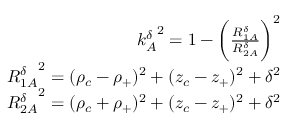<formula> <loc_0><loc_0><loc_500><loc_500>\begin{array} { r } { { k _ { A } ^ { \delta } } ^ { 2 } = 1 - \left ( \frac { R _ { 1 A } ^ { \delta } } { R _ { 2 A } ^ { \delta } } \right ) ^ { 2 } } \\ { { R _ { 1 A } ^ { \delta } } ^ { 2 } = ( \rho _ { c } - \rho _ { + } ) ^ { 2 } + ( z _ { c } - z _ { + } ) ^ { 2 } + \delta ^ { 2 } } \\ { { R _ { 2 A } ^ { \delta } } ^ { 2 } = ( \rho _ { c } + \rho _ { + } ) ^ { 2 } + ( z _ { c } - z _ { + } ) ^ { 2 } + \delta ^ { 2 } } \end{array}</formula> 